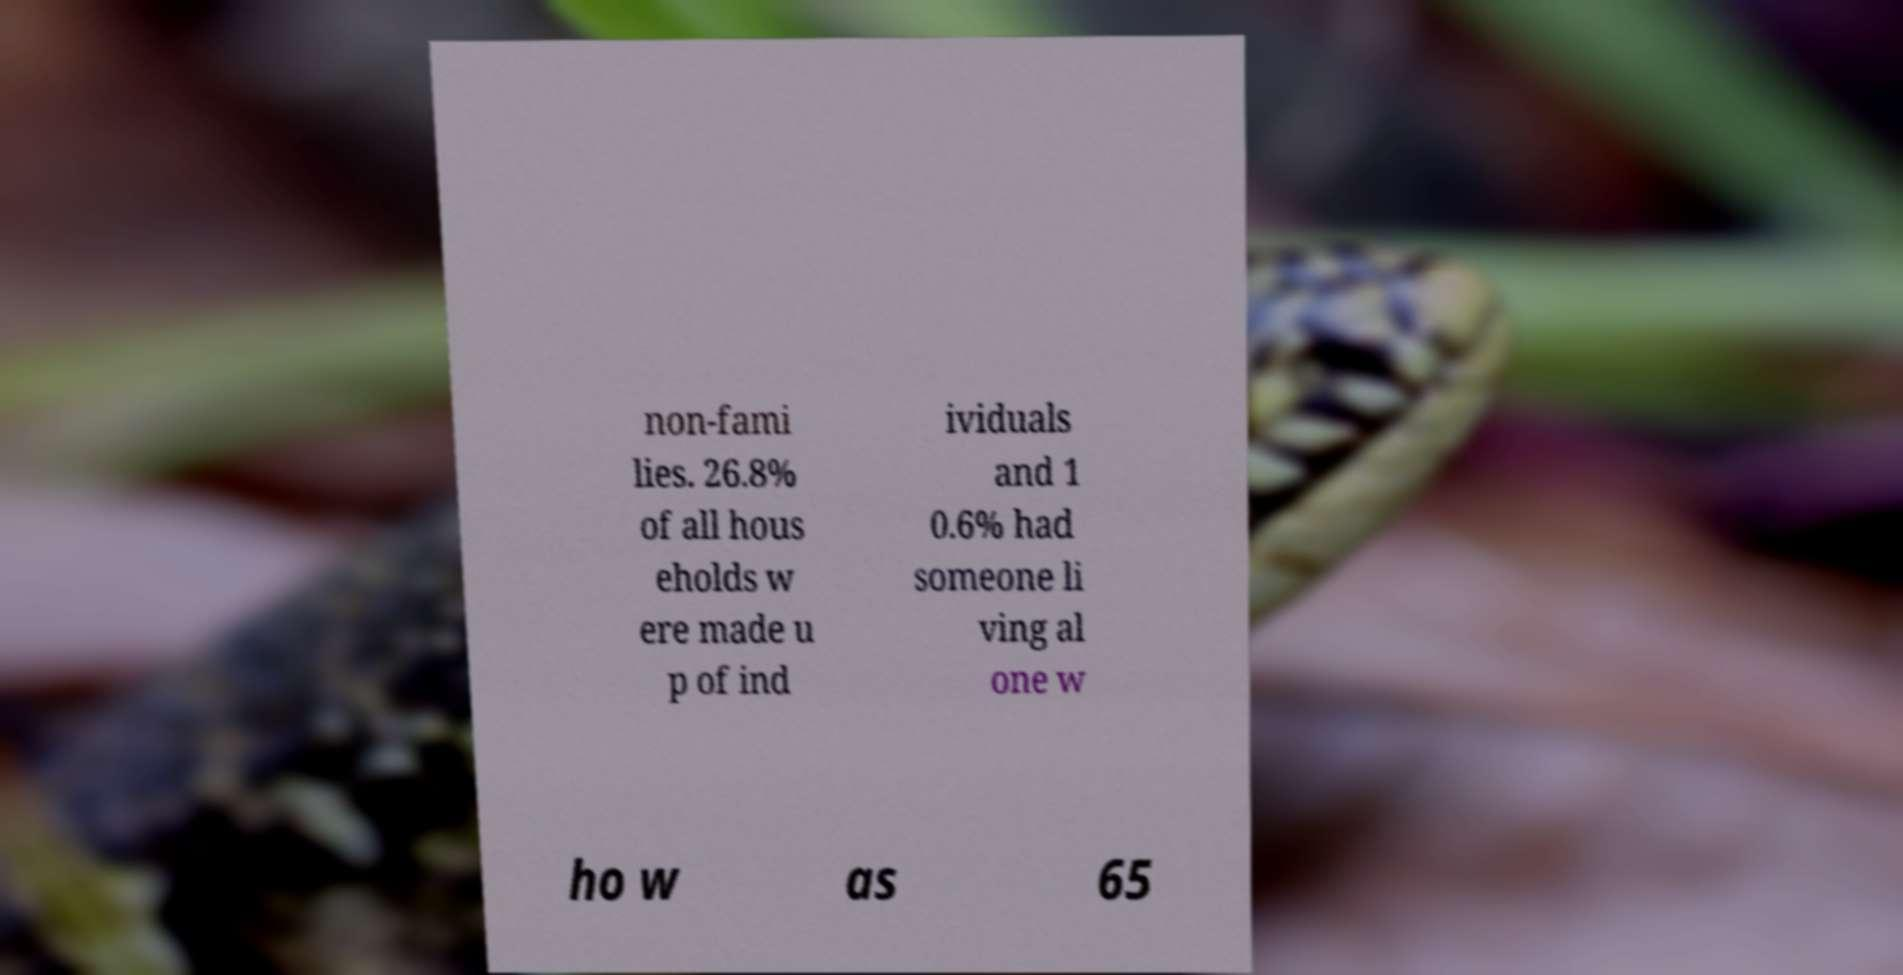Please read and relay the text visible in this image. What does it say? non-fami lies. 26.8% of all hous eholds w ere made u p of ind ividuals and 1 0.6% had someone li ving al one w ho w as 65 